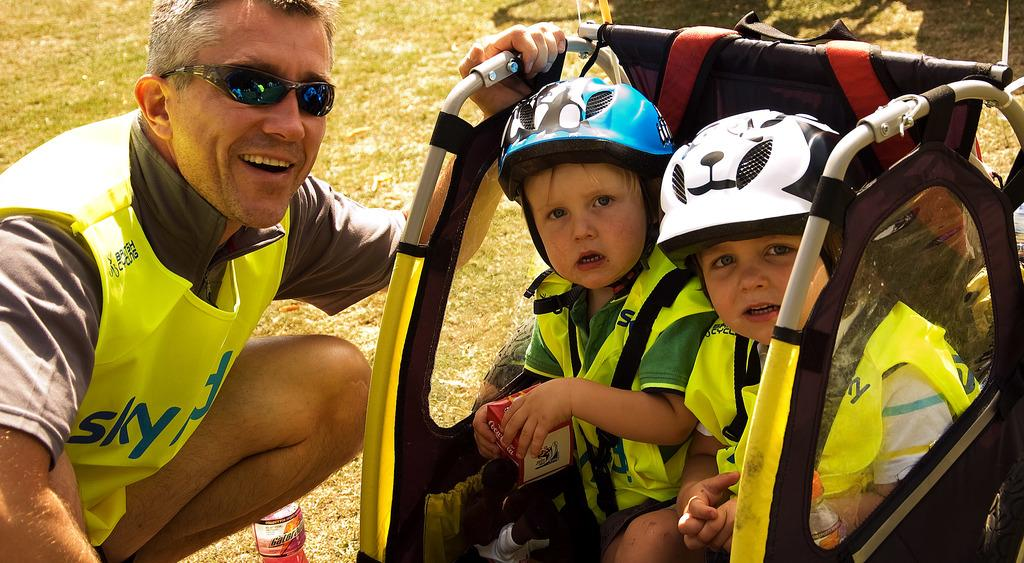How many people are wearing dresses in the image? There are three people with dresses in the image. What type of headgear is worn by two people in the image? Two people are wearing helmets in the image. What object are two people sitting on in the image? Two people are sitting on an object that resembles a stroller. What is the rhythm of the afternoon in the image? The image does not depict a specific rhythm or time of day, as it only shows people and their attire. 